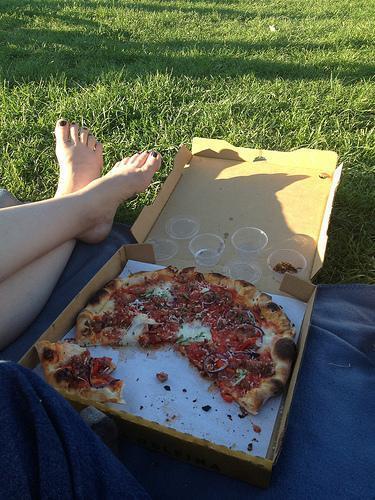How many feet are in the picture?
Give a very brief answer. 2. 